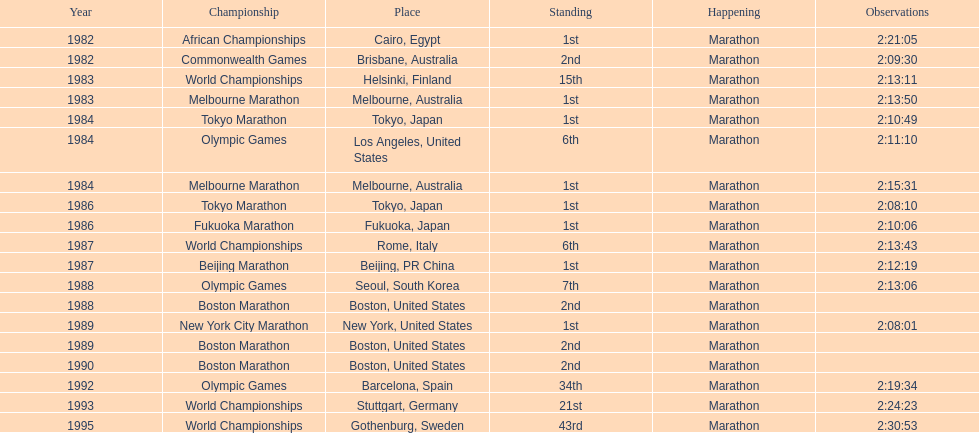How many times in total did ikangaa run the marathon in the olympic games? 3. 